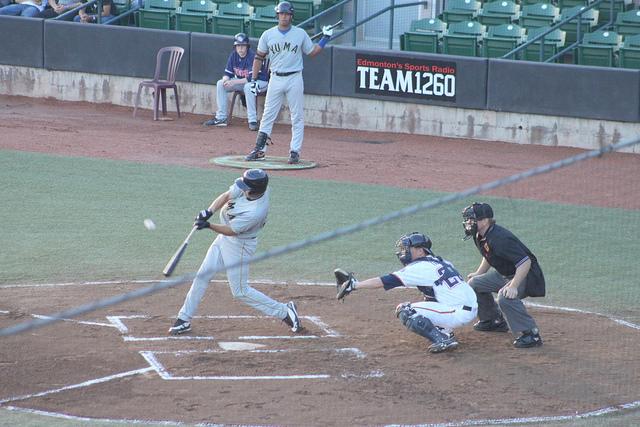Is the game crowded?
Be succinct. No. Did the catcher catch the ball?
Give a very brief answer. No. What game is this?
Give a very brief answer. Baseball. 